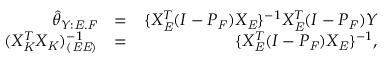Convert formula to latex. <formula><loc_0><loc_0><loc_500><loc_500>\begin{array} { r l r } { \hat { \theta } _ { Y \colon E . F } } & { = } & { \{ X _ { E } ^ { T } ( I - P _ { F } ) X _ { E } \} ^ { - 1 } X _ { E } ^ { T } ( I - P _ { F } ) Y } \\ { ( X _ { K } ^ { T } X _ { K } ) _ { ( E E ) } ^ { - 1 } } & { = } & { \{ X _ { E } ^ { T } ( I - P _ { F } ) X _ { E } \} ^ { - 1 } , } \end{array}</formula> 